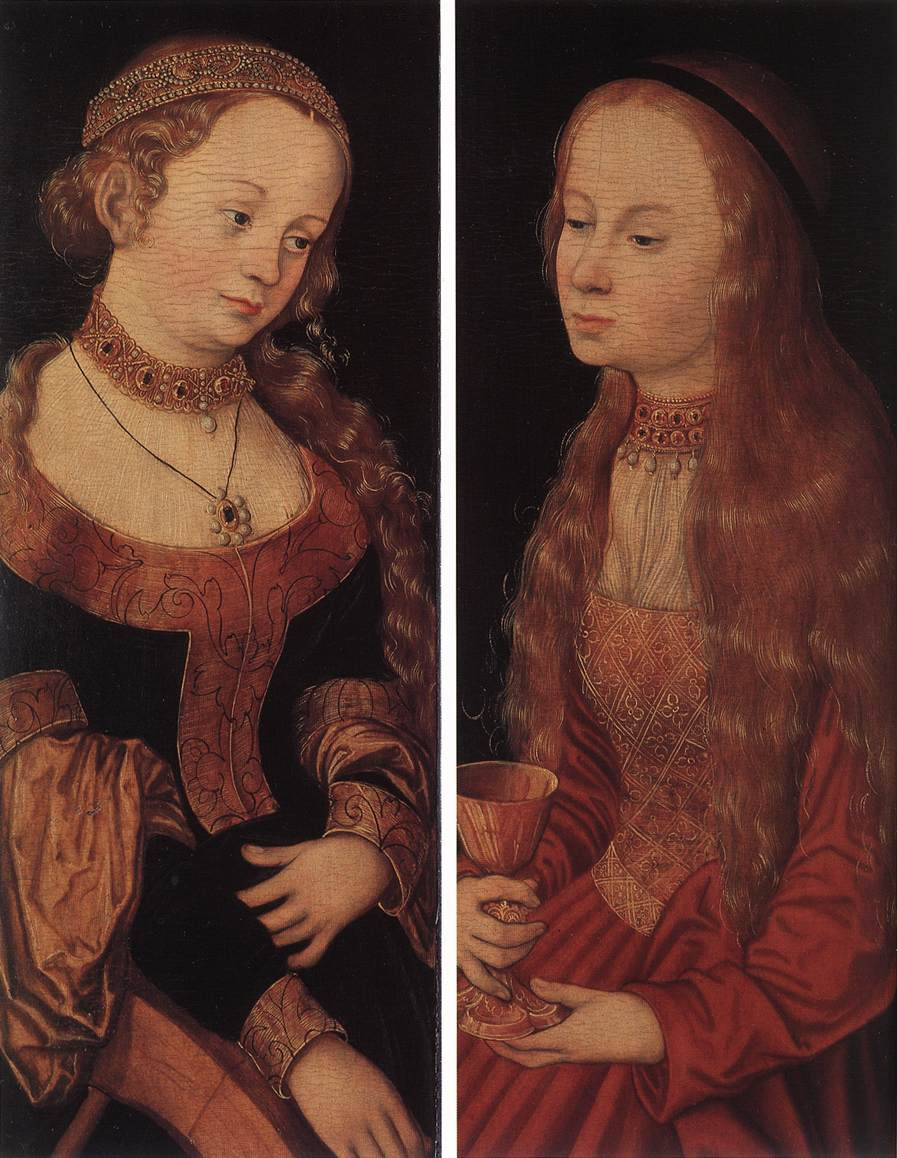What's the most imaginative story you can create about the origins of this painting? In a small town nestled in the heart of the Renaissance, lived a renowned but reclusive painter, rumored to have a magical brush that could capture souls on canvas. He was commissioned by a mystic order to create a painting of two sisters who were said to guard the gates to hidden realms of knowledge and abundance.

The painter, inspired one stormy night by a vision, saw the sisters in a forest clearing illuminated by an ethereal light. They appeared to him, not as ordinary women, but as celestial beings – one holding the Book of Eternal Knowledge, its pages seemingly written by stars, and the other a Golden Chalice filled with the Waters of Life.

Determined to capture their celestial essence, the painter worked tirelessly, infusing his creation with the very magic that binds the universe. The left panel depicts Sophia, Guardian of Knowledge, her expression serene and wise. The right showcases Auriel, Keeper of Abundance, her gaze inviting and profound. The painting, it is said, holds the power to reveal its secrets to those pure of heart and intent, where beholders might glimpse the hidden realms guarded by the eternal sisters. 